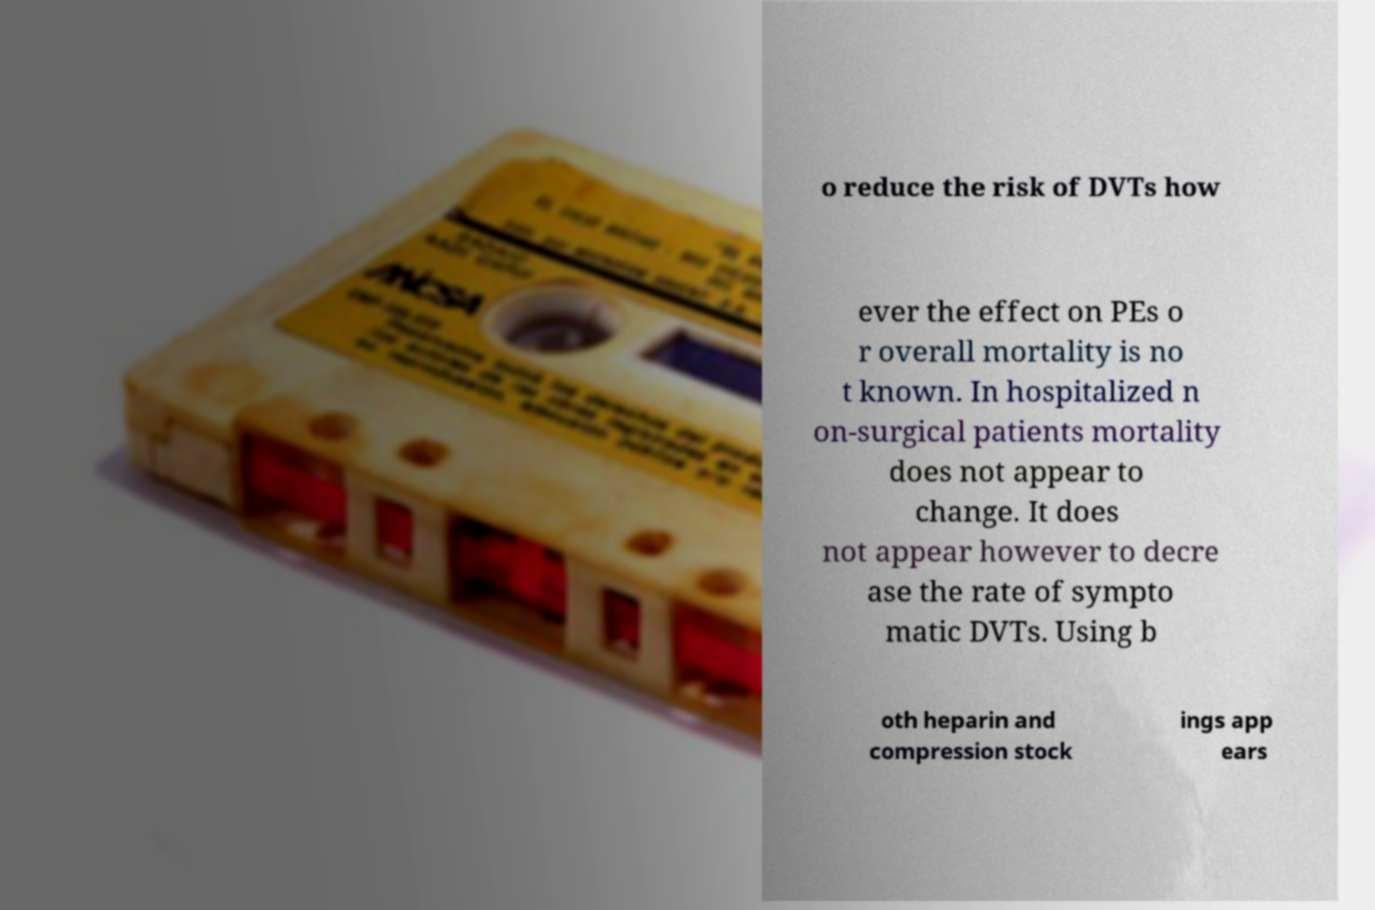There's text embedded in this image that I need extracted. Can you transcribe it verbatim? o reduce the risk of DVTs how ever the effect on PEs o r overall mortality is no t known. In hospitalized n on-surgical patients mortality does not appear to change. It does not appear however to decre ase the rate of sympto matic DVTs. Using b oth heparin and compression stock ings app ears 